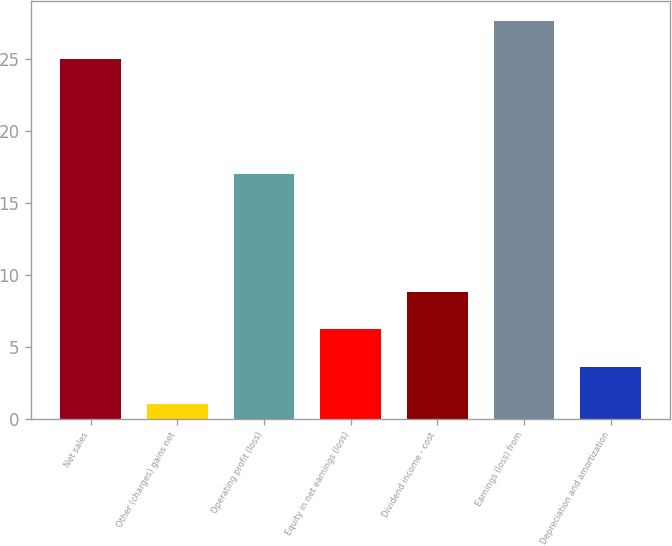Convert chart to OTSL. <chart><loc_0><loc_0><loc_500><loc_500><bar_chart><fcel>Net sales<fcel>Other (charges) gains net<fcel>Operating profit (loss)<fcel>Equity in net earnings (loss)<fcel>Dividend income - cost<fcel>Earnings (loss) from<fcel>Depreciation and amortization<nl><fcel>25<fcel>1<fcel>17<fcel>6.2<fcel>8.8<fcel>27.6<fcel>3.6<nl></chart> 